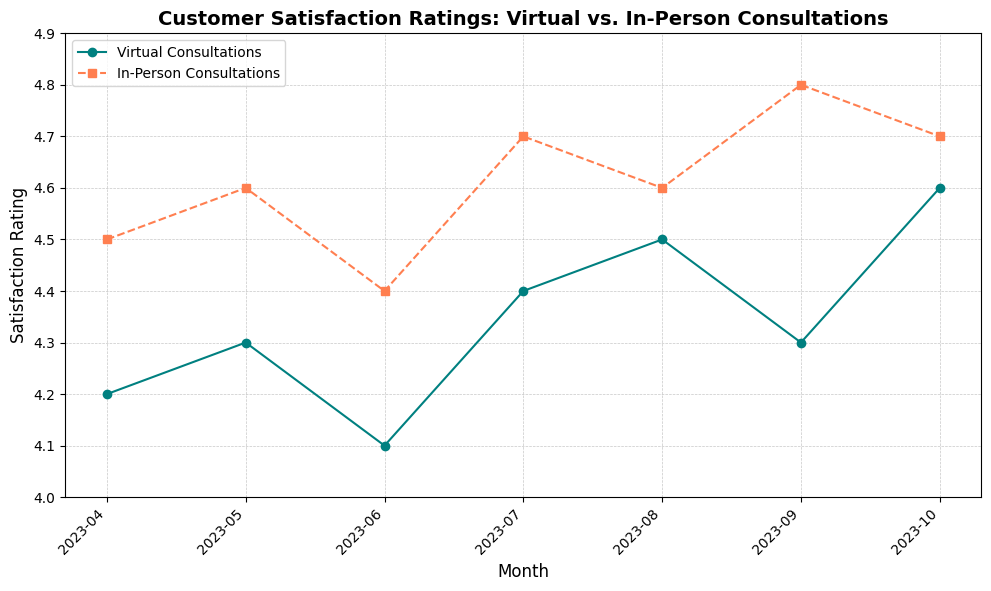What is the general trend of customer satisfaction for virtual consultations over the past six months? The customer satisfaction ratings for virtual consultations have shown a general uptick with a minor dip in June, starting at 4.2 in April and reaching 4.6 in October.
Answer: Increasing trend Which month had the highest satisfaction rating for in-person consultations? By checking the peaks on the in-person consultations line, we can see that the highest rating is in September at 4.8.
Answer: September How do the satisfaction ratings for virtual consultations compare to in-person consultations in October? In October, the rating for virtual consultations is 4.6, while for in-person consultations, it is 4.7. This shows that in-person consultations have a slightly higher rating.
Answer: In-person is higher What is the average satisfaction rating for virtual consultations over the six-month period? Sum the ratings for each month (4.2 + 4.3 + 4.1 + 4.4 + 4.5 + 4.3 + 4.6) and then divide by the number of months (7), which results in (29.4/7) ≈ 4.20.
Answer: 4.20 Compare the rating difference between virtual and in-person consultations in the month with the largest gap. The largest gap is in September, where in-person consultations are rated at 4.8 and virtual consultations at 4.3. The difference is 4.8 - 4.3 = 0.5.
Answer: 0.5 In which month did virtual consultations see their lowest satisfaction rating? By looking at the lowest point on the line for virtual consultations, we see that the lowest rating is in June with a rating of 4.1.
Answer: June During which month did virtual consultations witness the largest increase in satisfaction rating from the previous month? The largest increase can be observed between July and August, where the rating jumped from 4.4 to 4.5, a difference of 0.1.
Answer: From July to August Calculate the average monthly rating for in-person consultations in the first half and the second half of the period. For the first half: (4.5 + 4.6 + 4.4 + 4.7)/4 = 18.2/4 = 4.55. For the second half: (4.6 + 4.8 + 4.7)/3 = 14.1/3 ≈ 4.70.
Answer: First half: 4.55, Second half: 4.70 